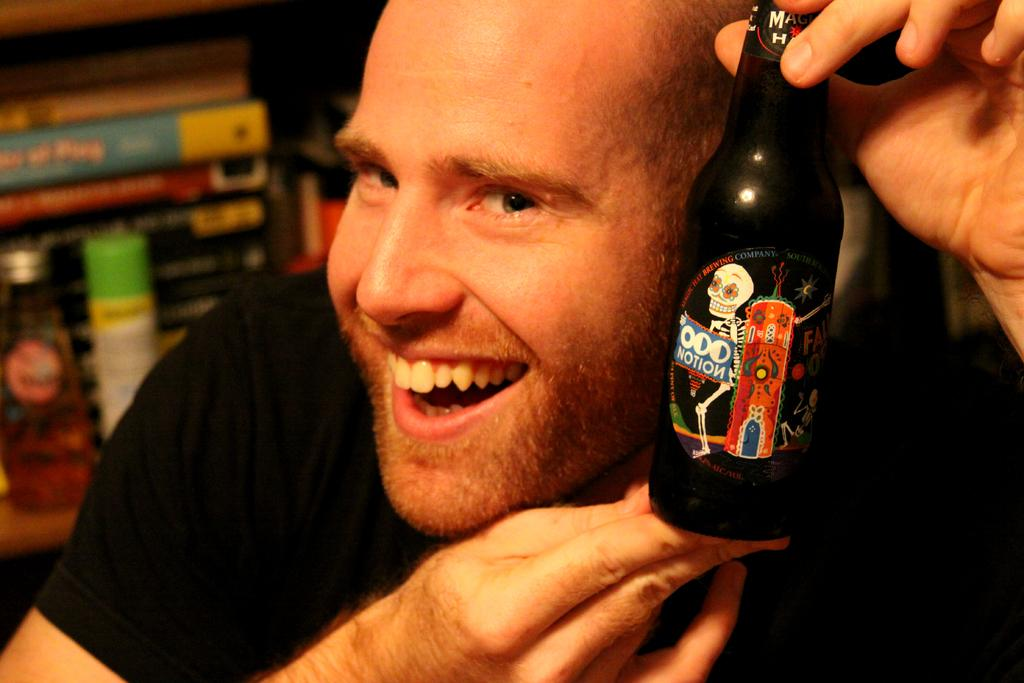What is the man in the image wearing? There is a man wearing a black color t-shirt in the image. What is the man holding in the image? There is a man holding a bottle in the image. What type of cabbage can be seen growing in the image? There is no cabbage present in the image. What type of leaf is visible on the man's t-shirt in the image? The man's t-shirt is described as black, and no leaves are mentioned or visible. What type of quiver is the man holding in the image? The man is holding a bottle in the image, not a quiver. 